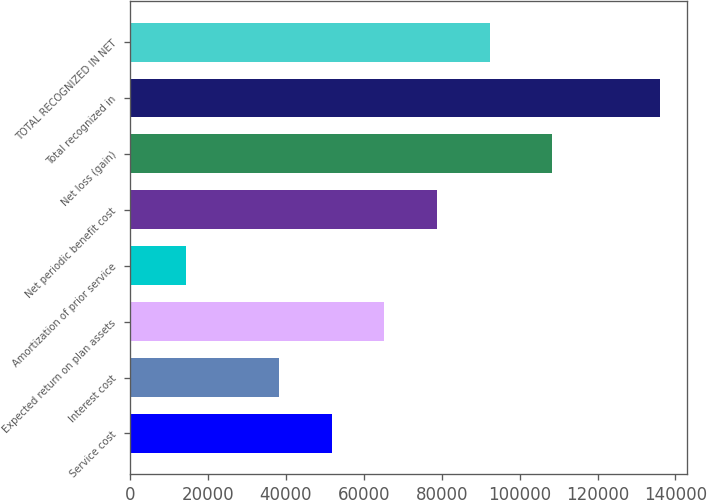Convert chart to OTSL. <chart><loc_0><loc_0><loc_500><loc_500><bar_chart><fcel>Service cost<fcel>Interest cost<fcel>Expected return on plan assets<fcel>Amortization of prior service<fcel>Net periodic benefit cost<fcel>Net loss (gain)<fcel>Total recognized in<fcel>TOTAL RECOGNIZED IN NET<nl><fcel>51763.3<fcel>38243<fcel>65283.6<fcel>14376.3<fcel>78803.9<fcel>108387<fcel>136059<fcel>92324.2<nl></chart> 